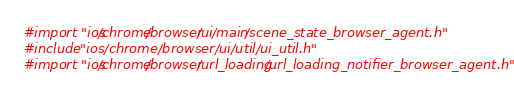Convert code to text. <code><loc_0><loc_0><loc_500><loc_500><_ObjectiveC_>#import "ios/chrome/browser/ui/main/scene_state_browser_agent.h"
#include "ios/chrome/browser/ui/util/ui_util.h"
#import "ios/chrome/browser/url_loading/url_loading_notifier_browser_agent.h"</code> 